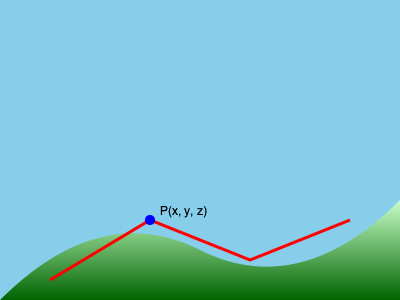In an adaptive parkour system for procedurally generated terrain represented by a height map, how would you efficiently calculate the normal vector at point P(x, y, z) to determine the optimal parkour move, given that the height map is stored as a 2D array H[i][j]? To calculate the normal vector at point P(x, y, z) on a height map efficiently, we can follow these steps:

1. Identify the grid cell: Determine which cell in the height map contains point P. Let's say it's at indices (i, j).

2. Calculate partial derivatives:
   a. For the x-direction: $\frac{\partial H}{\partial x} = \frac{H[i][j+1] - H[i][j-1]}{2\Delta x}$
   b. For the z-direction: $\frac{\partial H}{\partial z} = \frac{H[i+1][j] - H[i-1][j]}{2\Delta z}$

   Where $\Delta x$ and $\Delta z$ are the distances between grid points in the x and z directions, respectively.

3. Construct the normal vector:
   The normal vector N is perpendicular to both partial derivatives:
   $N = \left(-\frac{\partial H}{\partial x}, 1, -\frac{\partial H}{\partial z}\right)$

4. Normalize the vector:
   $N_{normalized} = \frac{N}{\|N\|} = \frac{N}{\sqrt{\left(\frac{\partial H}{\partial x}\right)^2 + 1 + \left(\frac{\partial H}{\partial z}\right)^2}}$

5. Use the normalized normal vector to determine the surface orientation and select the appropriate parkour move based on predefined criteria (e.g., wall run for near-vertical surfaces, jumps for gaps, etc.).

This method provides a fast approximation of the surface normal using central differences, which is suitable for real-time parkour mechanics in a game environment.
Answer: Calculate partial derivatives of H, construct normal vector $N = \left(-\frac{\partial H}{\partial x}, 1, -\frac{\partial H}{\partial z}\right)$, normalize, use for move selection. 